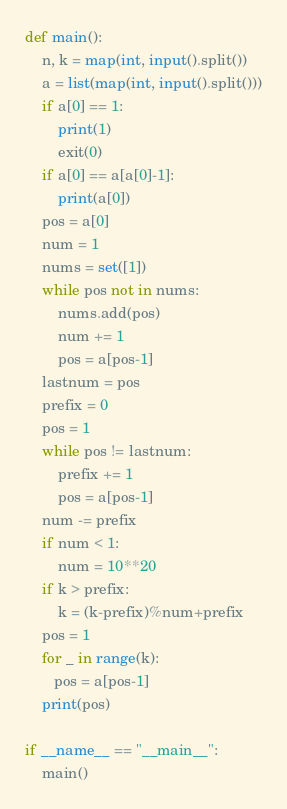Convert code to text. <code><loc_0><loc_0><loc_500><loc_500><_Python_>def main():
    n, k = map(int, input().split())
    a = list(map(int, input().split()))
    if a[0] == 1:
        print(1)
        exit(0)
    if a[0] == a[a[0]-1]:
        print(a[0])
    pos = a[0]
    num = 1
    nums = set([1])
    while pos not in nums:
        nums.add(pos)
        num += 1
        pos = a[pos-1]
    lastnum = pos
    prefix = 0
    pos = 1
    while pos != lastnum:
        prefix += 1
        pos = a[pos-1]
    num -= prefix
    if num < 1:
        num = 10**20
    if k > prefix:
        k = (k-prefix)%num+prefix
    pos = 1
    for _ in range(k):
       pos = a[pos-1]
    print(pos)

if __name__ == "__main__":
    main()</code> 